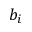<formula> <loc_0><loc_0><loc_500><loc_500>b _ { i }</formula> 